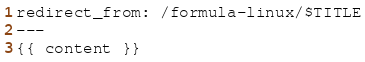Convert code to text. <code><loc_0><loc_0><loc_500><loc_500><_HTML_>redirect_from: /formula-linux/$TITLE
---
{{ content }}
</code> 